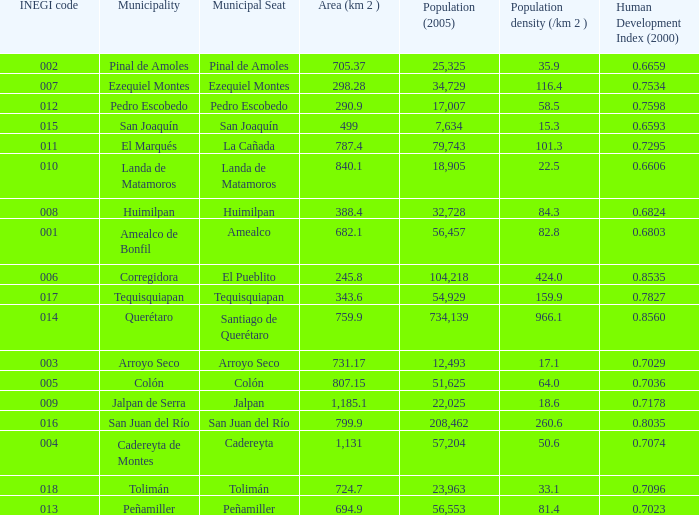WHat is the amount of Human Development Index (2000) that has a Population (2005) of 54,929, and an Area (km 2 ) larger than 343.6? 0.0. 